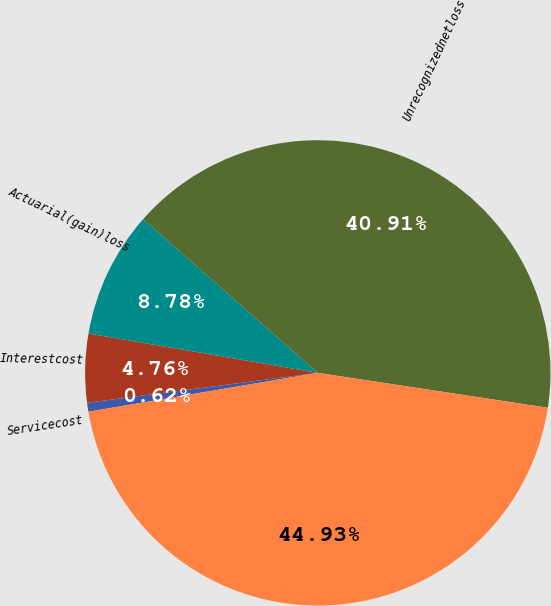<chart> <loc_0><loc_0><loc_500><loc_500><pie_chart><fcel>Servicecost<fcel>Interestcost<fcel>Actuarial(gain)loss<fcel>Unrecognizednetloss<fcel>Unnamed: 4<nl><fcel>0.62%<fcel>4.76%<fcel>8.78%<fcel>40.91%<fcel>44.93%<nl></chart> 